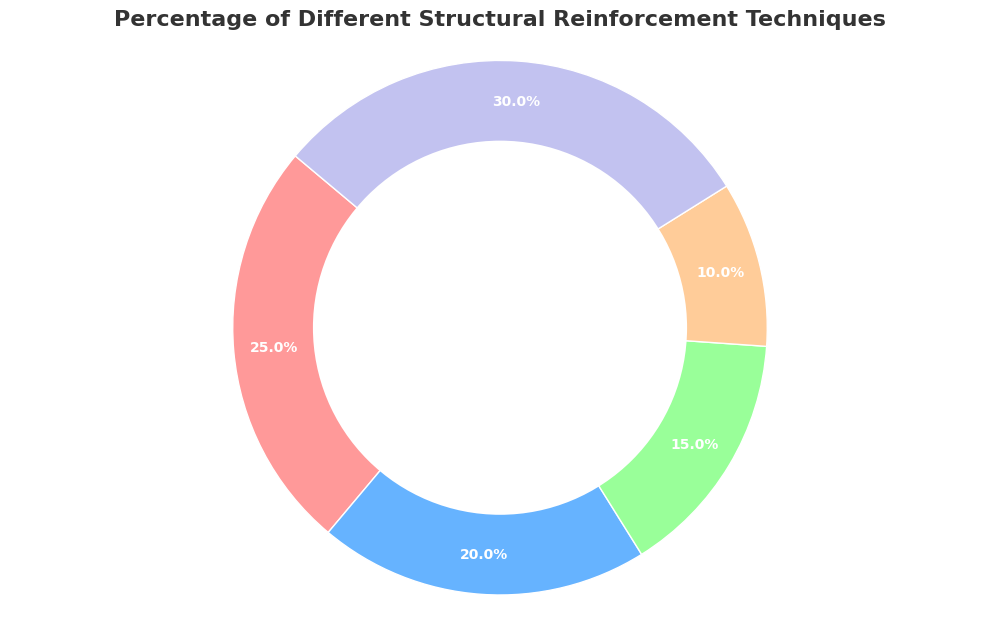Which structural reinforcement technique is represented by the largest slice? "Other" is the largest slice because it covers the biggest area in the pie chart.
Answer: Other Which technique has the smallest percentage? Geogrid has the smallest slice in the pie chart, indicating it has the smallest percentage.
Answer: Geogrid What is the total percentage for buttresses and arches combined? Adding the percentages for buttresses (25%) and arches (20%) gives a total of 25% + 20% = 45%.
Answer: 45% How does the percentage of tie rods compare to geogrid? Tie rods have a 15% slice, whereas geogrid has a 10% slice, so tie rods have a greater percentage.
Answer: Tie rods have a greater percentage Which techniques together make up less than half of the total percentage? Adding the percentages for geogrid (10%) and tie rods (15%) gives a total of 10% + 15% = 25%, which is less than 50%. Similarly, for geogrid and arches: 10% + 20% = 30%, and for tie rods and arches: 15% + 20% = 35%. Thus, geogrid and tie rods together, geogrid and arches together, and tie rods and arches together make up less than half of the total percentage.
Answer: Geogrid and tie rods, Geogrid and arches, and Tie rods and arches What is the average percentage of the reinforcement techniques excluding "Other"? Adding the percentages of buttresses (25%), arches (20%), tie rods (15%), and geogrid (10%) and dividing by the number of techniques (4), we get (25% + 20% + 15% + 10%) / 4 = 70% / 4 = 17.5%.
Answer: 17.5% If you combine the percentages of geogrid and tie rods, does it exceed the percentage of buttresses? Adding geogrid (10%) and tie rods (15%) gives 10% + 15% = 25%, which is equal to the percentage of buttresses (25%). Thus, it does not exceed it.
Answer: No What color is used to represent the technique with the highest percentage? The technique with the highest percentage is "Other" (30%), and the color used is a light purple or lavender shade.
Answer: Light purple/lavender What is the percentage difference between the techniques with the highest and lowest percentages? The highest percentage is "Other" (30%), and the lowest is "Geogrid" (10%). The difference is 30% - 10% = 20%.
Answer: 20% 